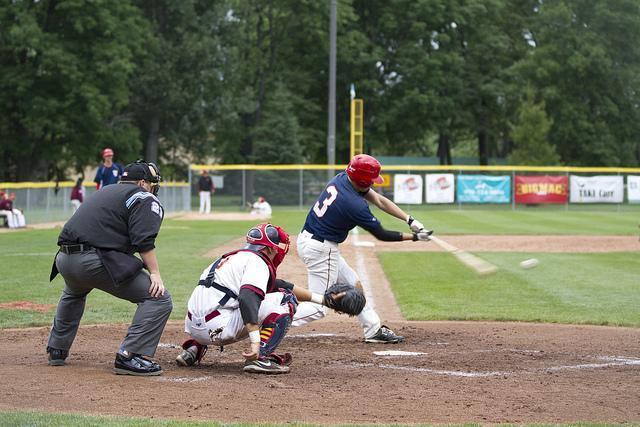How many signs are in the back?
Give a very brief answer. 6. How many people are in the picture?
Give a very brief answer. 3. 